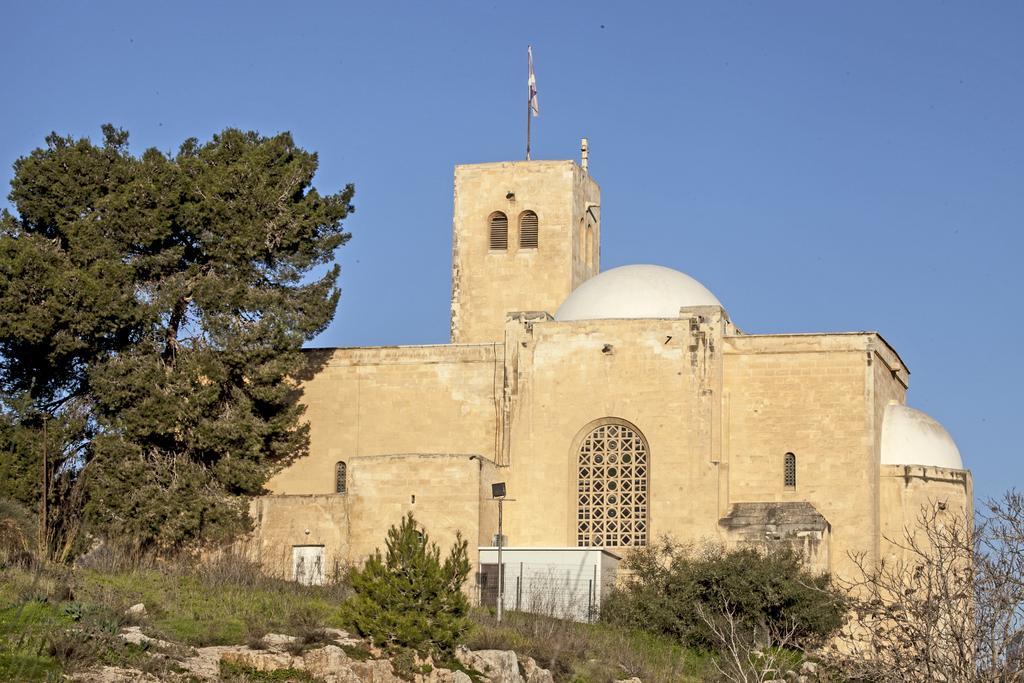In one or two sentences, can you explain what this image depicts? In this picture I can see there is a building and it has windows, there is a flag pole and a flag on the building. There are rocks, plants, trees at right and left sides. The sky is clear 